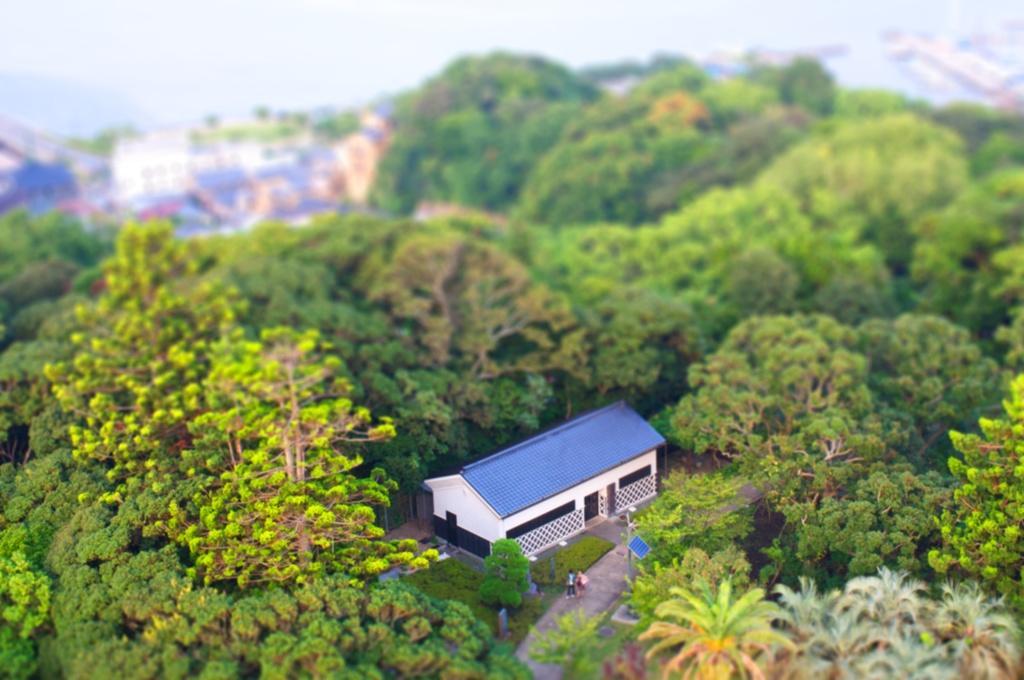Could you give a brief overview of what you see in this image? In this image I can see number trees and in the centre of this image I can see a building and two persons are standing. I can also see this image is little bit blurry in the background. 